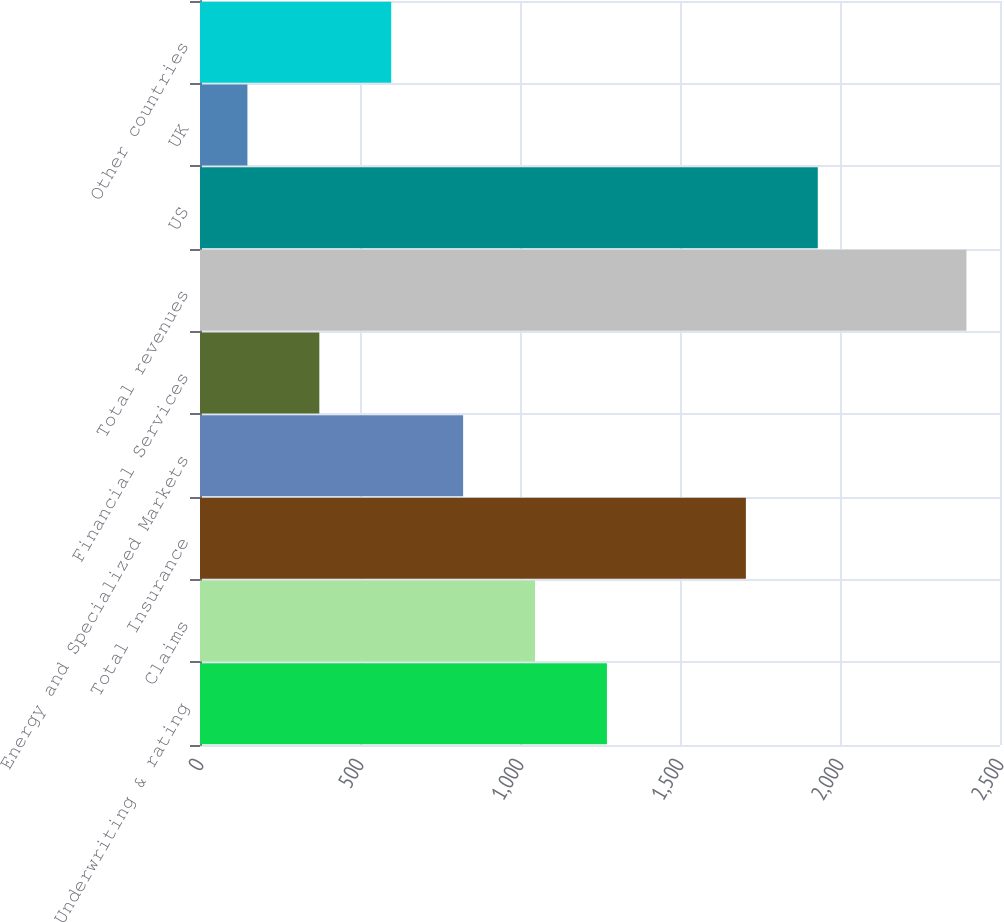Convert chart to OTSL. <chart><loc_0><loc_0><loc_500><loc_500><bar_chart><fcel>Underwriting & rating<fcel>Claims<fcel>Total Insurance<fcel>Energy and Specialized Markets<fcel>Financial Services<fcel>Total revenues<fcel>US<fcel>UK<fcel>Other countries<nl><fcel>1271.65<fcel>1046.96<fcel>1705.9<fcel>822.27<fcel>372.89<fcel>2395.1<fcel>1930.59<fcel>148.2<fcel>597.58<nl></chart> 